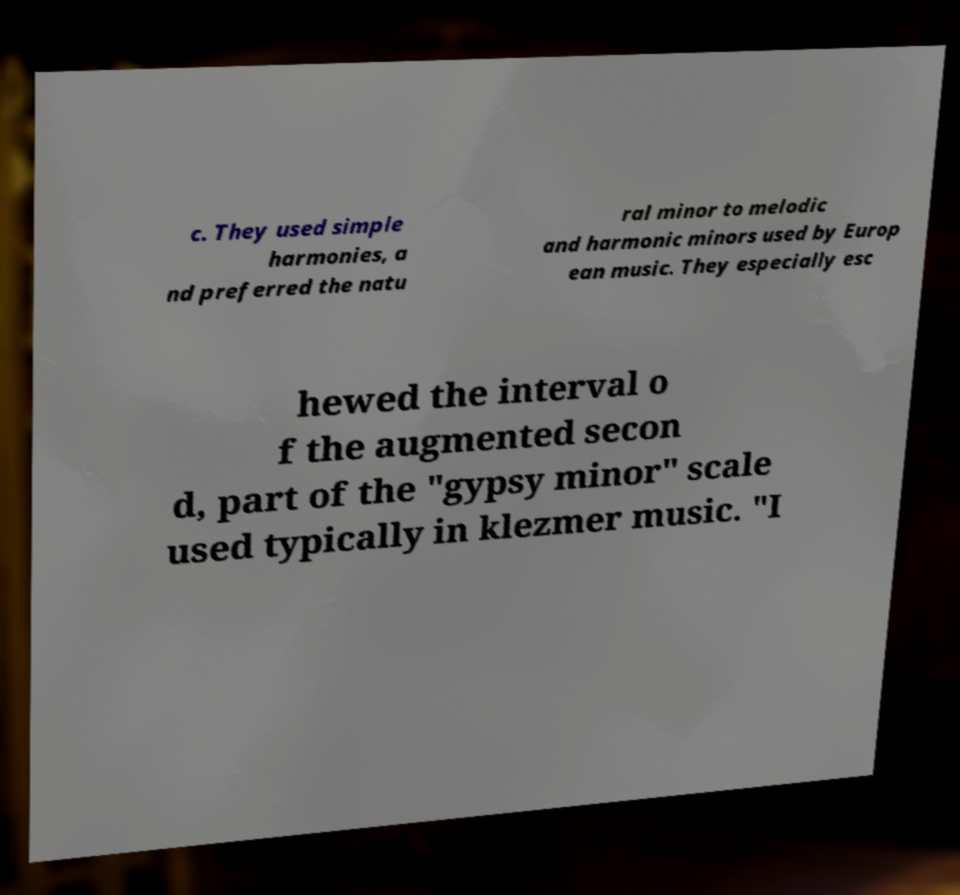For documentation purposes, I need the text within this image transcribed. Could you provide that? c. They used simple harmonies, a nd preferred the natu ral minor to melodic and harmonic minors used by Europ ean music. They especially esc hewed the interval o f the augmented secon d, part of the "gypsy minor" scale used typically in klezmer music. "I 